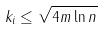Convert formula to latex. <formula><loc_0><loc_0><loc_500><loc_500>k _ { i } \leq \sqrt { 4 m \ln n }</formula> 